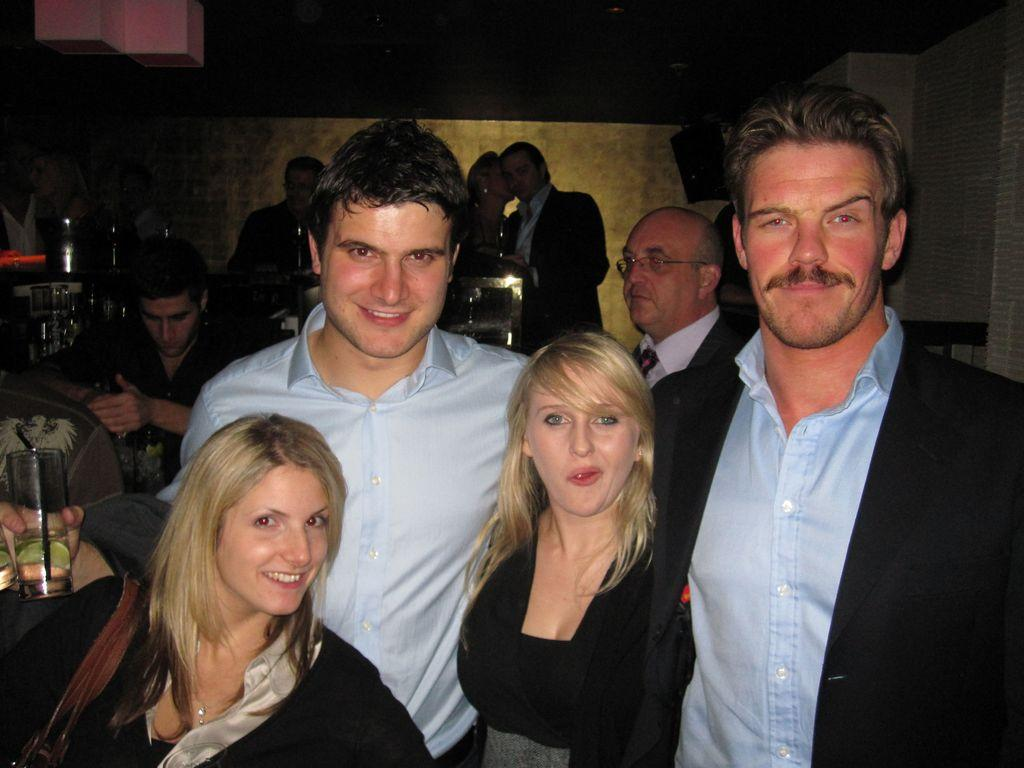What are the people in the image doing? There are people sitting on chairs and standing in the image. Can you describe the positions of the people in the image? Some people are sitting on chairs, while others are standing. What type of summer activity is being performed by the people in the image? There is no specific summer activity mentioned or depicted in the image. Can you hear a cough from any of the people in the image? The image does not provide any auditory information, so it is impossible to determine if anyone is coughing. 